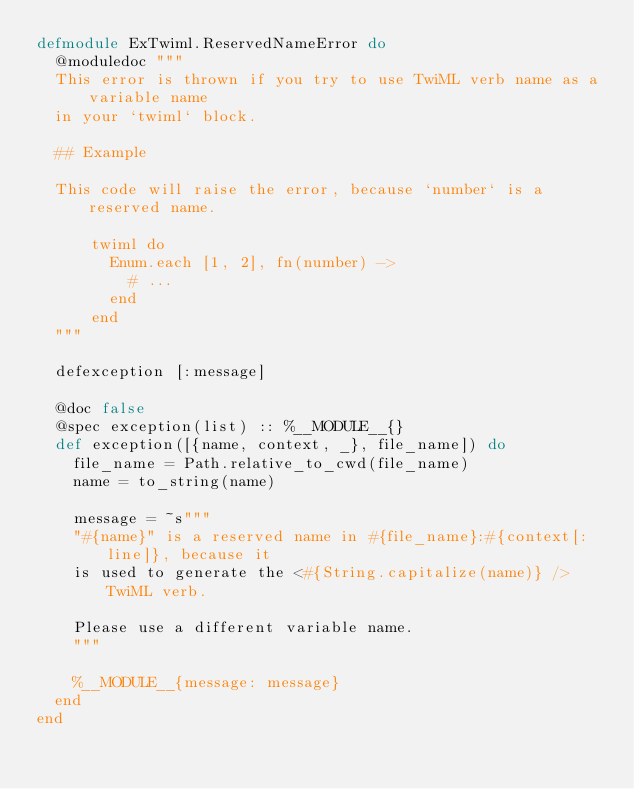Convert code to text. <code><loc_0><loc_0><loc_500><loc_500><_Elixir_>defmodule ExTwiml.ReservedNameError do
  @moduledoc """
  This error is thrown if you try to use TwiML verb name as a variable name
  in your `twiml` block.

  ## Example

  This code will raise the error, because `number` is a reserved name.

      twiml do
        Enum.each [1, 2], fn(number) ->
          # ...
        end
      end
  """

  defexception [:message]

  @doc false
  @spec exception(list) :: %__MODULE__{}
  def exception([{name, context, _}, file_name]) do
    file_name = Path.relative_to_cwd(file_name)
    name = to_string(name)

    message = ~s"""
    "#{name}" is a reserved name in #{file_name}:#{context[:line]}, because it
    is used to generate the <#{String.capitalize(name)} /> TwiML verb.

    Please use a different variable name.
    """

    %__MODULE__{message: message}
  end
end
</code> 